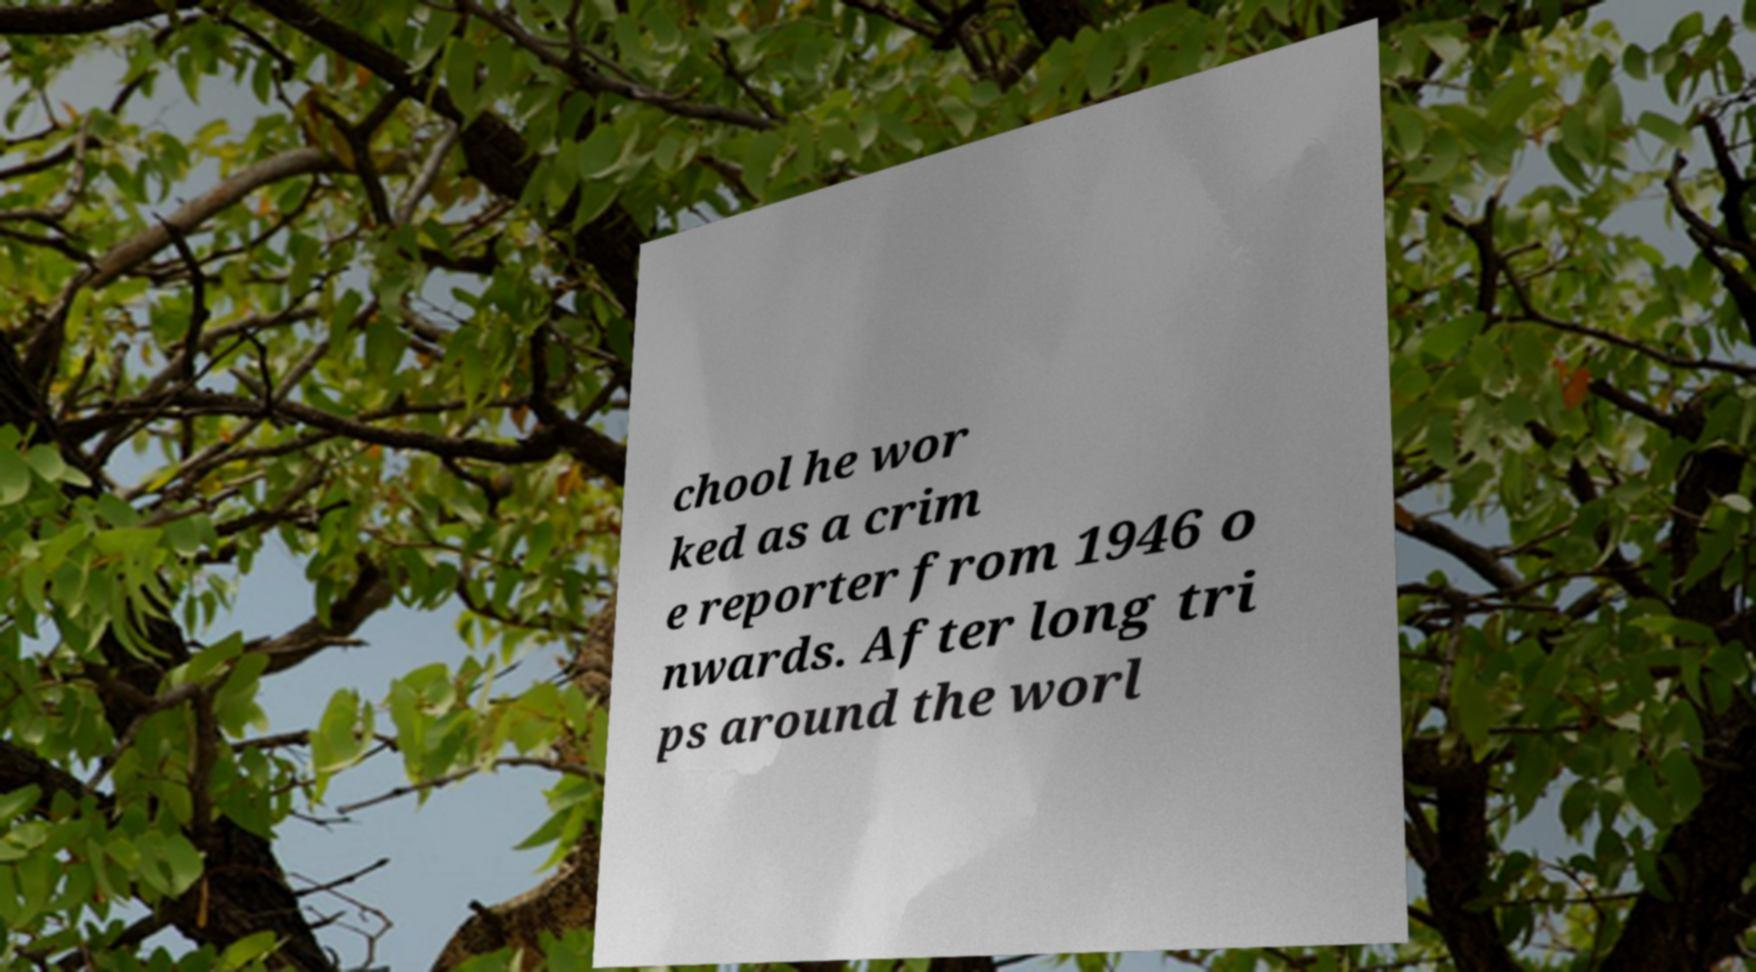Could you assist in decoding the text presented in this image and type it out clearly? chool he wor ked as a crim e reporter from 1946 o nwards. After long tri ps around the worl 